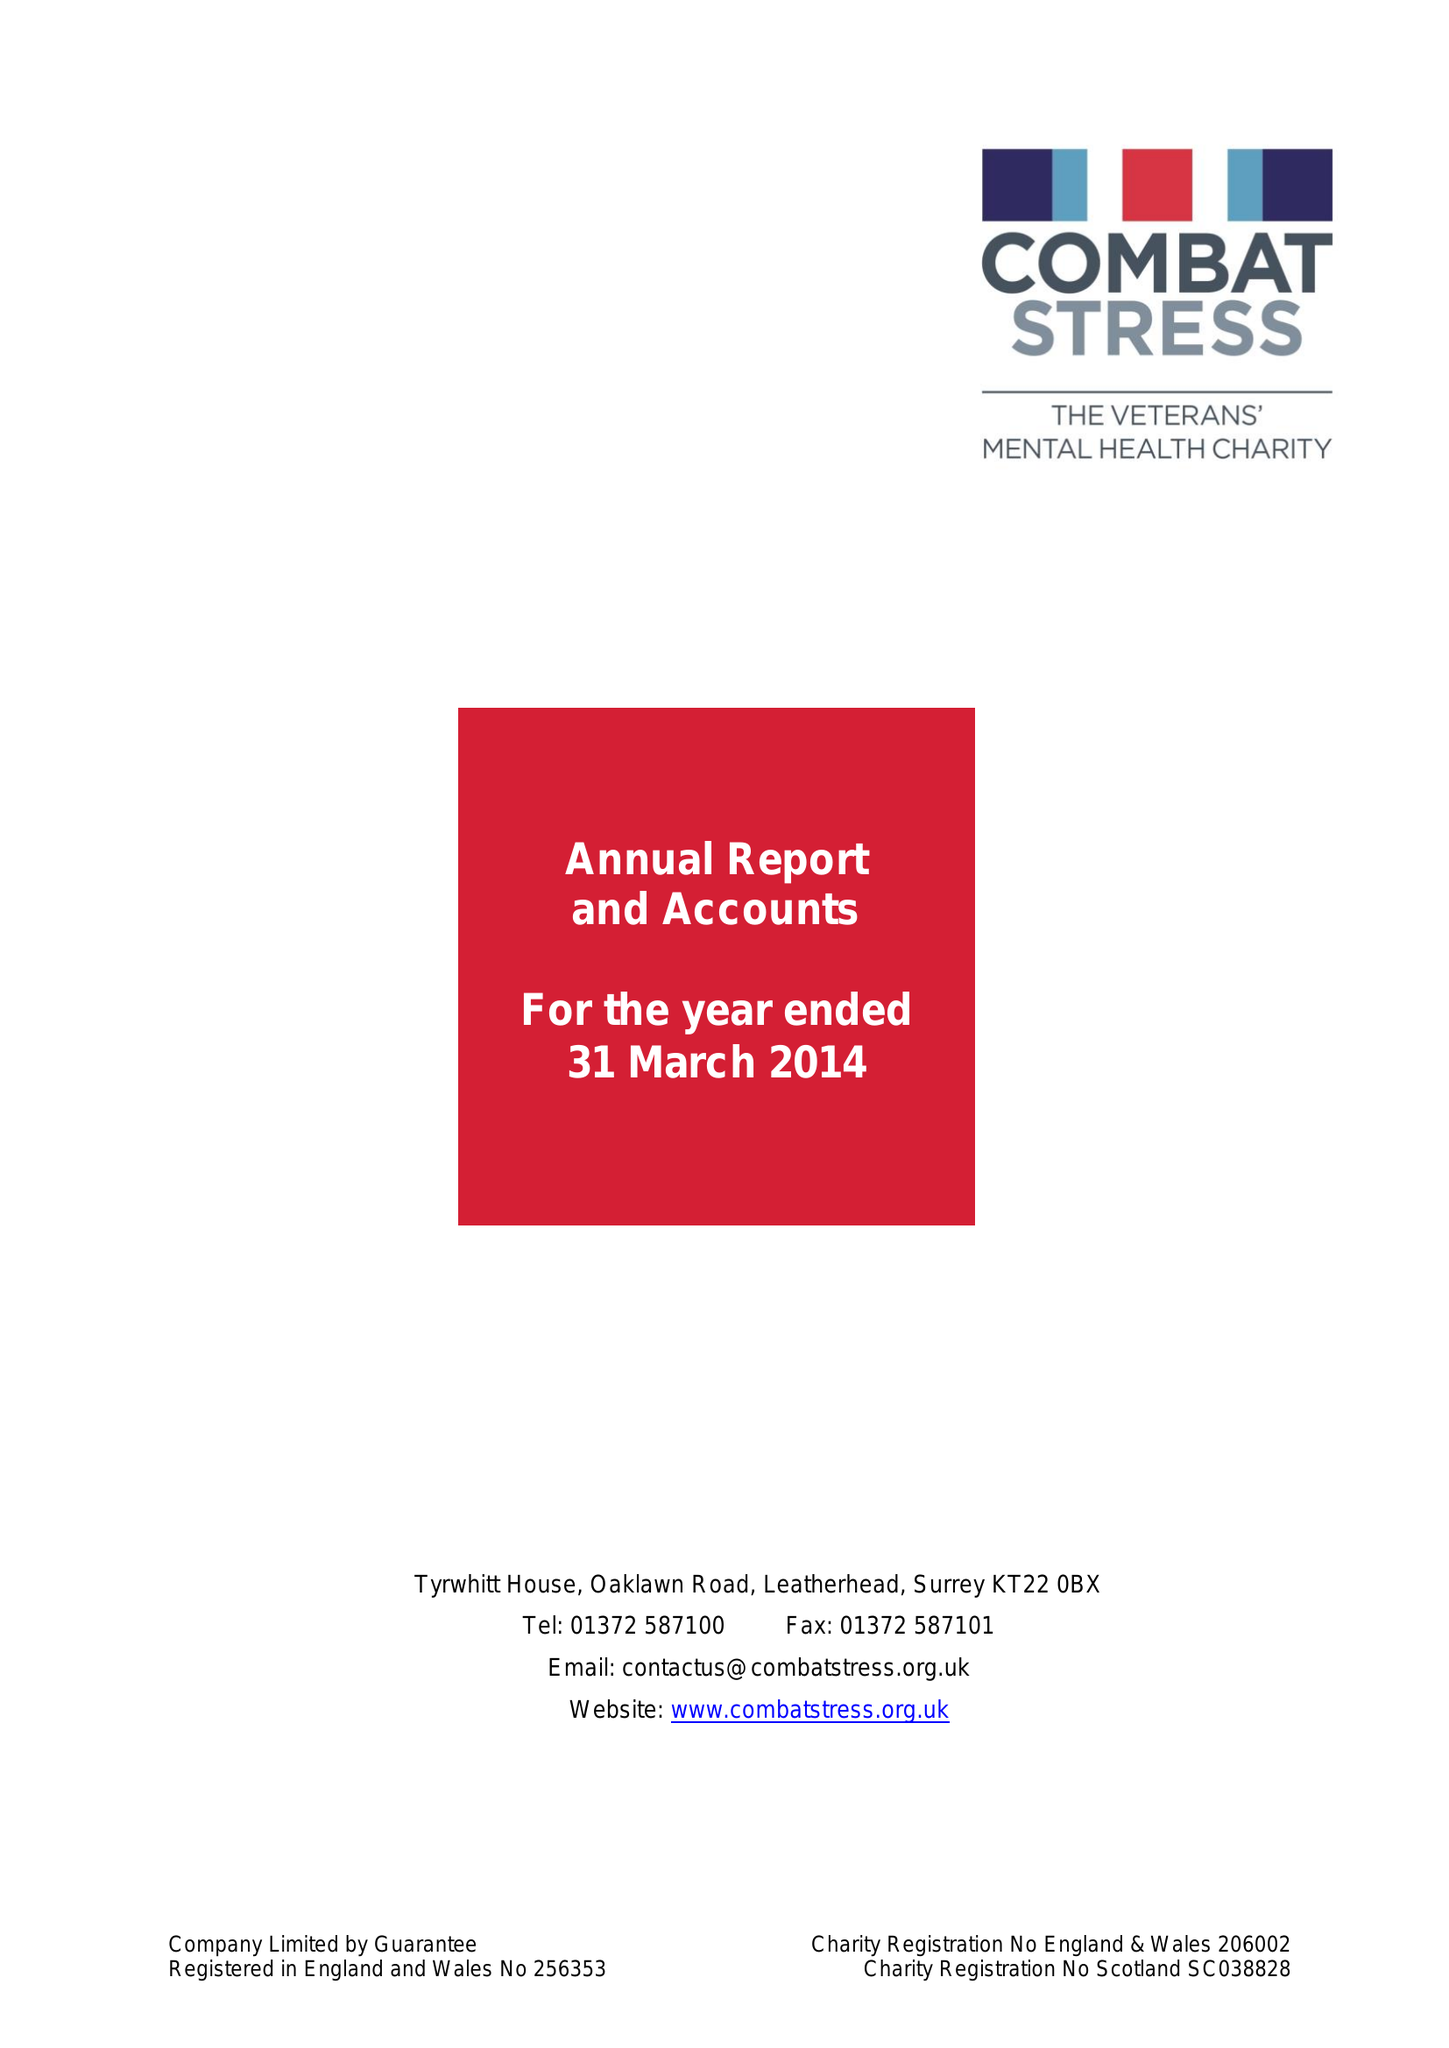What is the value for the address__post_town?
Answer the question using a single word or phrase. LEATHERHEAD 